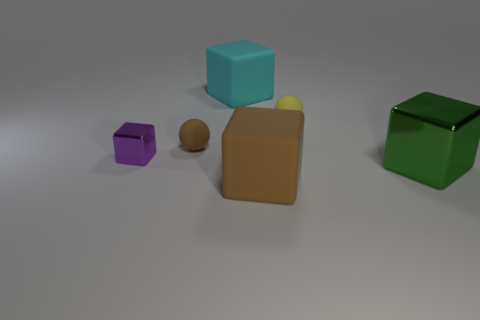Add 2 tiny yellow things. How many objects exist? 8 Subtract all big brown cubes. How many cubes are left? 3 Subtract all brown cubes. How many cubes are left? 3 Subtract all green cubes. Subtract all brown matte blocks. How many objects are left? 4 Add 4 matte balls. How many matte balls are left? 6 Add 6 tiny cyan balls. How many tiny cyan balls exist? 6 Subtract 0 blue balls. How many objects are left? 6 Subtract all blocks. How many objects are left? 2 Subtract 1 spheres. How many spheres are left? 1 Subtract all blue balls. Subtract all gray blocks. How many balls are left? 2 